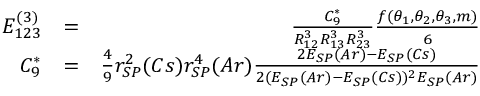Convert formula to latex. <formula><loc_0><loc_0><loc_500><loc_500>\begin{array} { r l r } { E _ { 1 2 3 } ^ { ( 3 ) } } & { = } & { \frac { C _ { 9 } ^ { * } } { R _ { 1 2 } ^ { 3 } R _ { 1 3 } ^ { 3 } R _ { 2 3 } ^ { 3 } } \frac { f ( \theta _ { 1 } , \theta _ { 2 } , \theta _ { 3 } , m ) } { 6 } } \\ { C _ { 9 } ^ { * } } & { = } & { \frac { 4 } { 9 } r _ { S P } ^ { 2 } ( C s ) r _ { S P } ^ { 4 } ( A r ) \frac { 2 E _ { S P } ( A r ) - E _ { S P } ( C s ) } { 2 ( E _ { S P } ( A r ) - E _ { S P } ( C s ) ) ^ { 2 } E _ { S P } ( A r ) } } \end{array}</formula> 